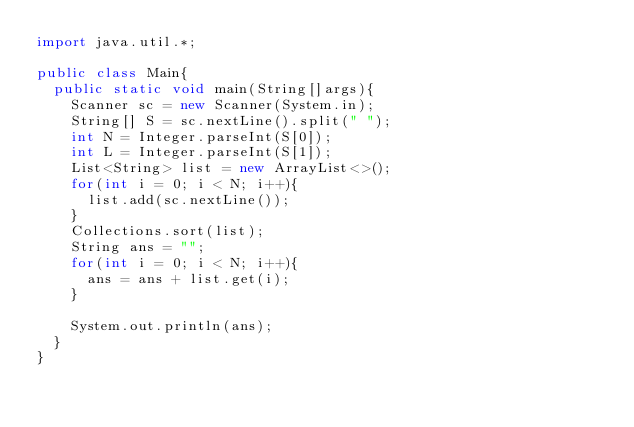<code> <loc_0><loc_0><loc_500><loc_500><_Java_>import java.util.*;

public class Main{
  public static void main(String[]args){
    Scanner sc = new Scanner(System.in);
    String[] S = sc.nextLine().split(" ");
    int N = Integer.parseInt(S[0]);
    int L = Integer.parseInt(S[1]);
    List<String> list = new ArrayList<>();
    for(int i = 0; i < N; i++){
      list.add(sc.nextLine());
    }
    Collections.sort(list);
    String ans = "";
    for(int i = 0; i < N; i++){
      ans = ans + list.get(i);
    }
    
    System.out.println(ans);
  }
}</code> 